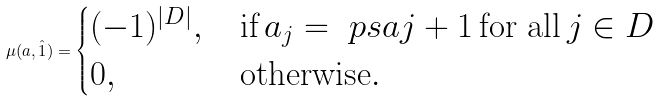<formula> <loc_0><loc_0><loc_500><loc_500>\mu ( a , \hat { 1 } ) = \begin{cases} ( - 1 ) ^ { | D | } , & \, \text {if} \, a _ { j } = \ p s { a } { j } + 1 \, \text {for all} \, j \in D \\ 0 , & \, \text {otherwise} . \end{cases}</formula> 